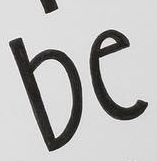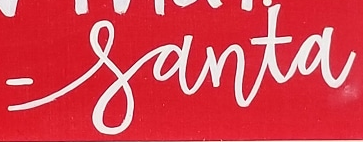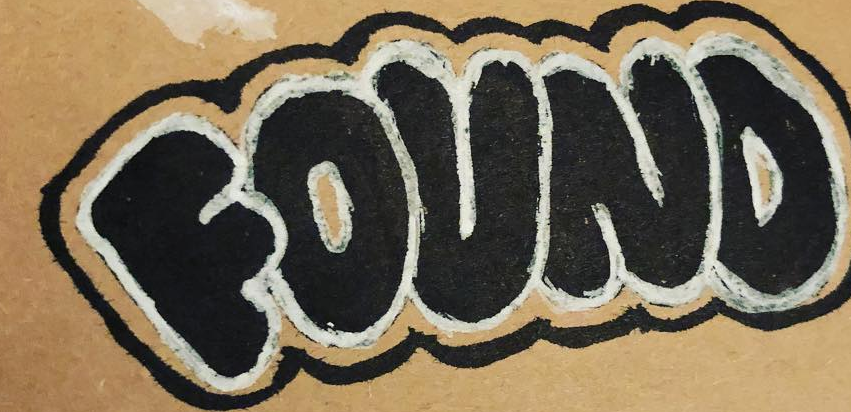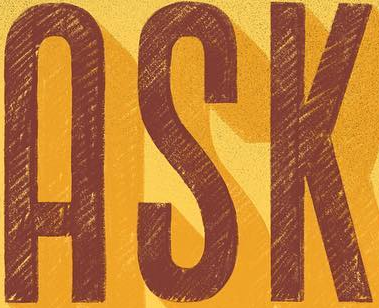What text appears in these images from left to right, separated by a semicolon? be; -santa; FOUND; ASK 